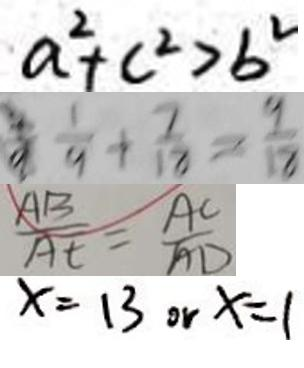<formula> <loc_0><loc_0><loc_500><loc_500>a ^ { 2 } + c ^ { 2 } > b ^ { 2 } 
 \frac { 1 } { 9 } + \frac { 7 } { 1 8 } = \frac { 9 } { 1 8 } 
 \frac { A B } { A E } = \frac { A C } { A D } 
 x = 1 3 o r x = 1 1</formula> 